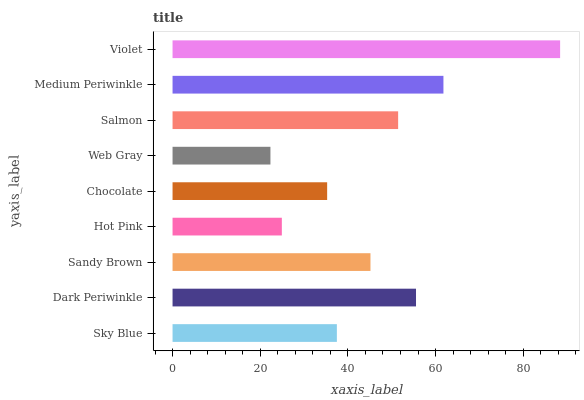Is Web Gray the minimum?
Answer yes or no. Yes. Is Violet the maximum?
Answer yes or no. Yes. Is Dark Periwinkle the minimum?
Answer yes or no. No. Is Dark Periwinkle the maximum?
Answer yes or no. No. Is Dark Periwinkle greater than Sky Blue?
Answer yes or no. Yes. Is Sky Blue less than Dark Periwinkle?
Answer yes or no. Yes. Is Sky Blue greater than Dark Periwinkle?
Answer yes or no. No. Is Dark Periwinkle less than Sky Blue?
Answer yes or no. No. Is Sandy Brown the high median?
Answer yes or no. Yes. Is Sandy Brown the low median?
Answer yes or no. Yes. Is Sky Blue the high median?
Answer yes or no. No. Is Salmon the low median?
Answer yes or no. No. 